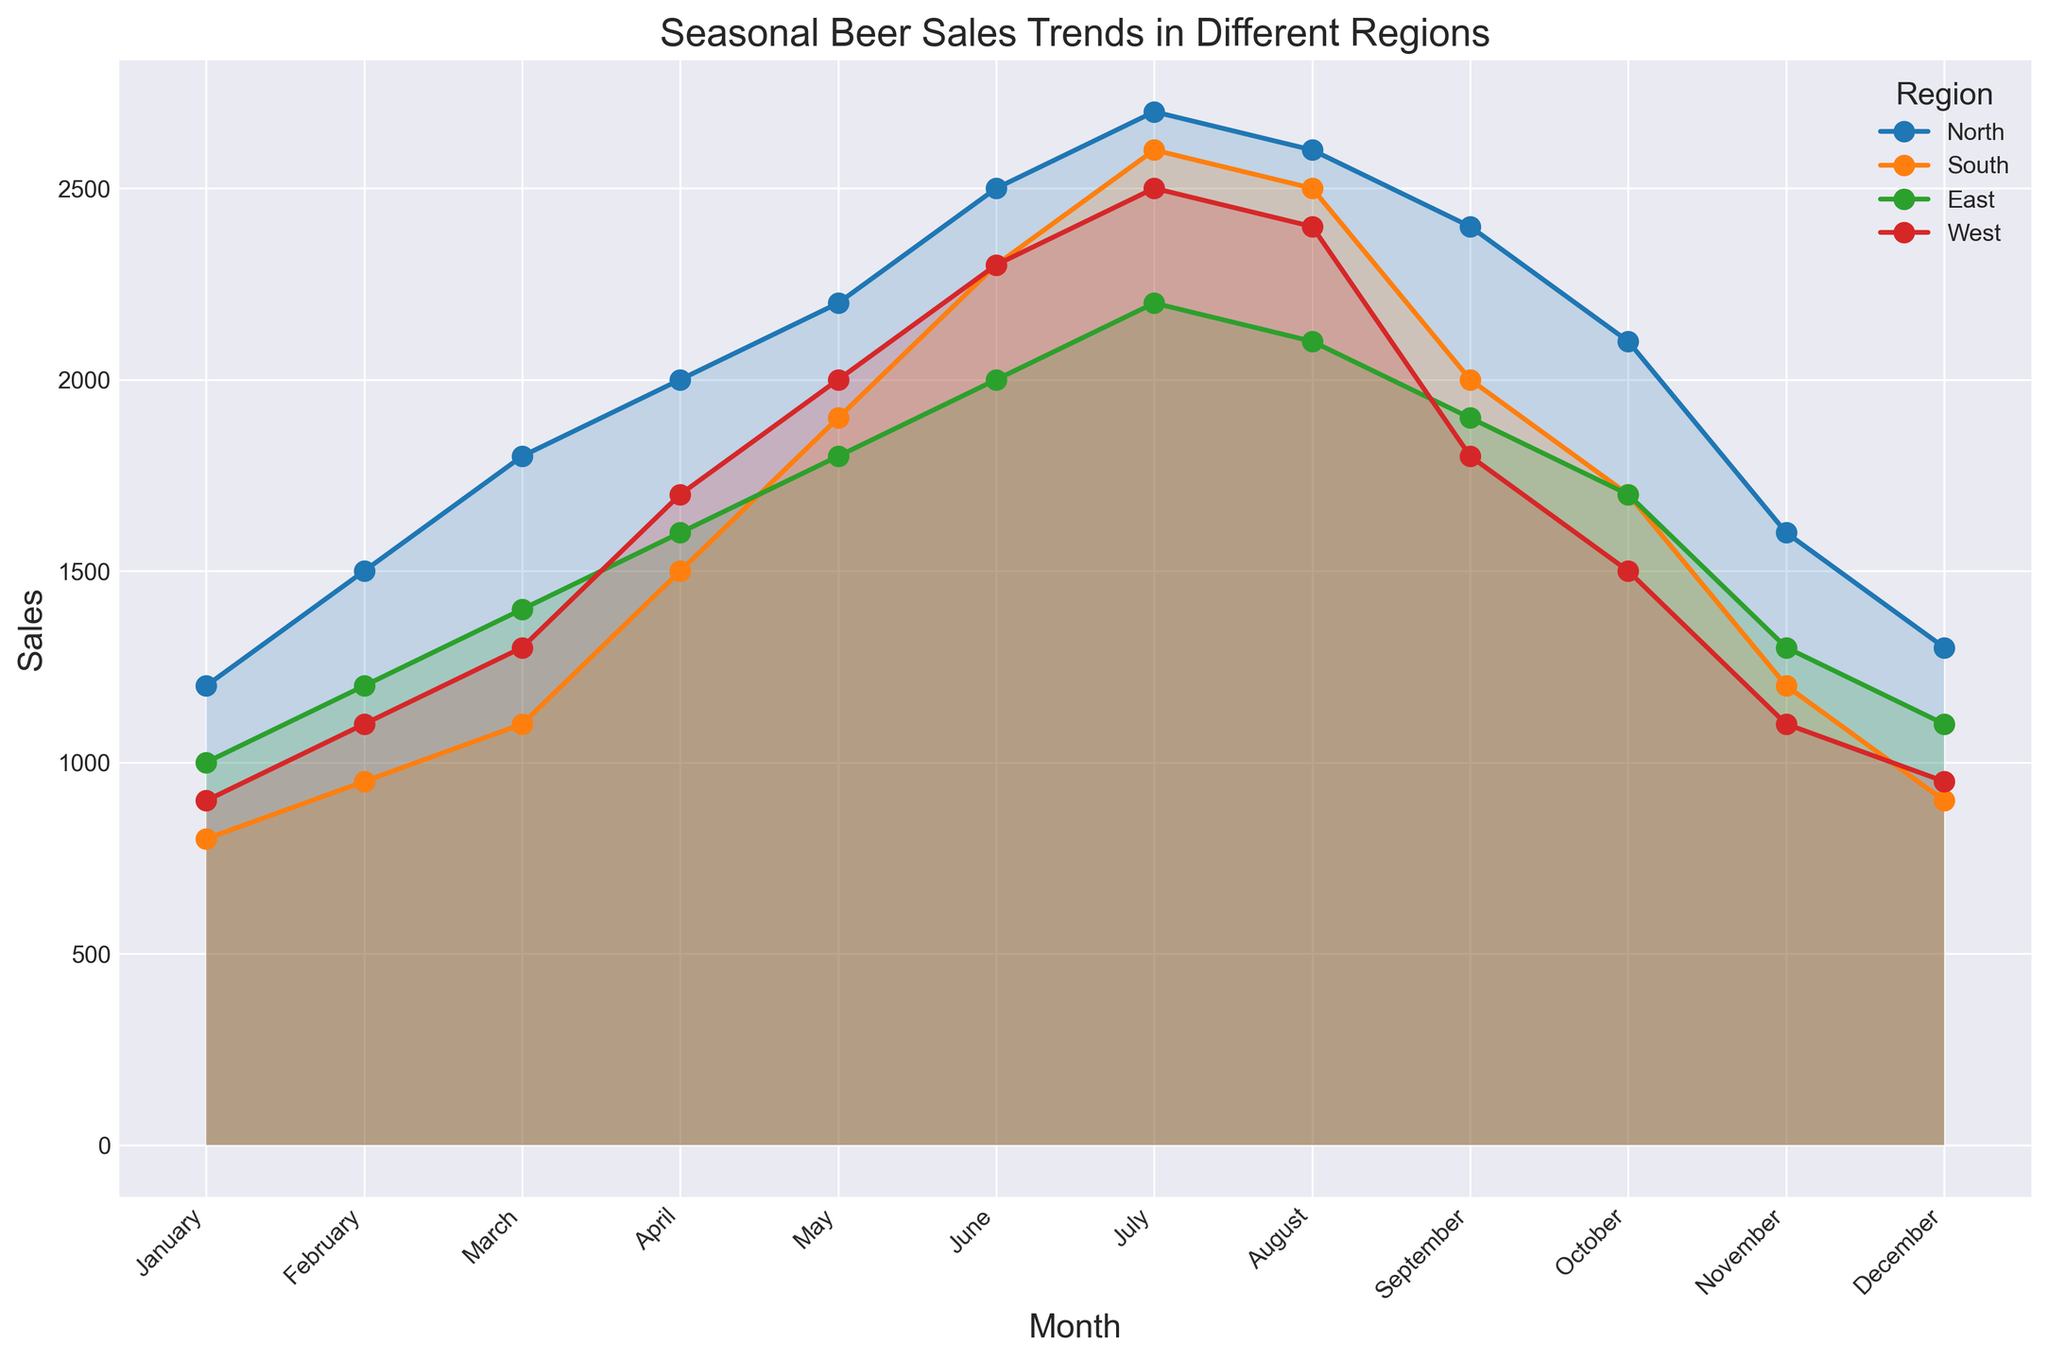Which region has the highest sales in July? By examining the line chart, we can see that the Northern region has the highest peak in July, reaching 2700 sales compared to the other regions.
Answer: North What is the difference in beer sales between the North and South regions in December? December sales for the North region are 1300 and for the South region are 900. The difference is 1300 - 900 = 400.
Answer: 400 Which month shows the lowest beer sales for the West region? By looking at the line representing the West region, the lowest point on the chart is in January with 900 sales.
Answer: January How do the sales trends of the East and South regions compare from March to June? For both East and South regions, there is a consistent increase in sales from March to June. Specifically, for the East: March (1400) to June (2000) shows an increase of 600, and for the South: March (1100) to June (2300) shows an increase of 1200.
Answer: Both increase, but South increases more steeply What is the average sales value for the East region over the entire year? Sum all monthly sales values for the East region: (1000 + 1200 + 1400 + 1600 + 1800 + 2000 + 2200 + 2100 + 1900 + 1700 + 1300 + 1100) = 20300. There are 12 months, so the average is 20300 / 12 = 1691.67.
Answer: 1691.67 In which month does the North region reach its peak sales, and what is the value? By visually identifying the highest point of the North region's line, the peak is in July with a sales value of 2700.
Answer: July, 2700 Does the South region ever surpass the North region in sales in any month? By comparing both regions' lines month by month, the South region does not surpass the North region in any month; the North always has higher sales.
Answer: No What is the total sales difference between the South and West regions for the first quarter (Jan-Mar)? Calculate both regions' sales for January, February, and March: South (800 + 950 + 1100) = 2850, West (900 + 1100 + 1300) = 3300. The difference is 3300 - 2850 = 450.
Answer: 450 How do the sales trends of all regions compare in November? By examining the line positions in November, the North region has the highest sales (1600), followed by the East (1300), the West (1100), and the South has the lowest (1200).
Answer: North>East>South>West 